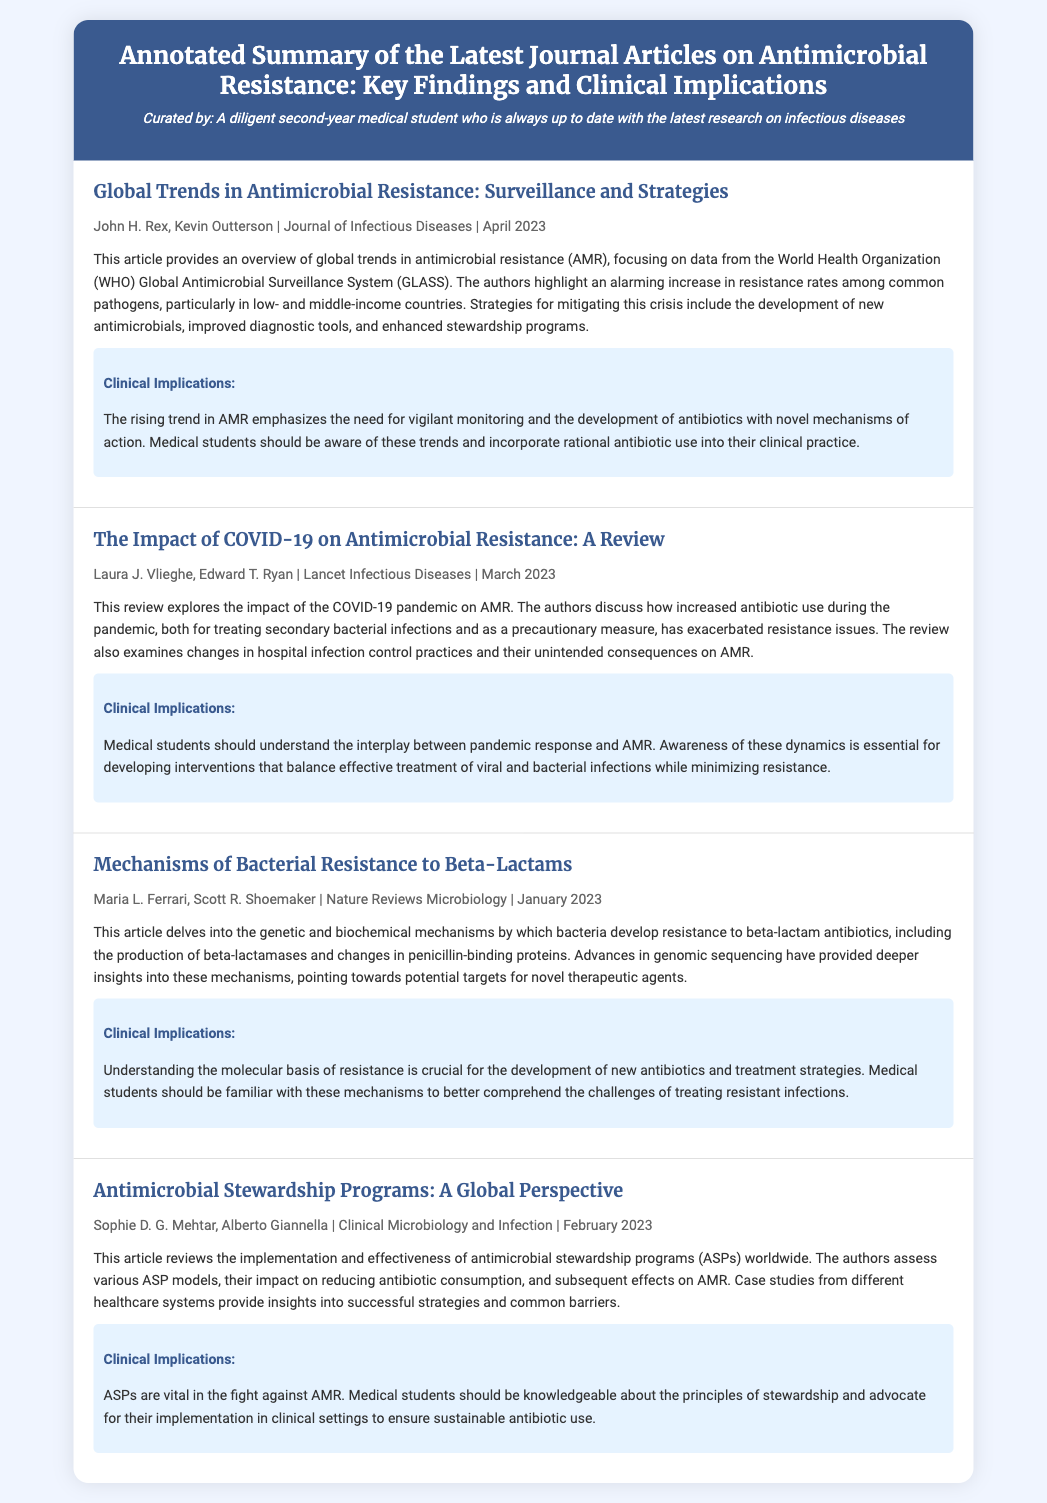What is the title of the first article? The title of the first article is provided in the document under the articles section.
Answer: Global Trends in Antimicrobial Resistance: Surveillance and Strategies Who are the authors of the article on COVID-19's impact on AMR? The authors are mentioned in the metadata of the article.
Answer: Laura J. Vlieghe, Edward T. Ryan What journal published the article discussing beta-lactams? The journal is specified in the metadata of the respective article.
Answer: Nature Reviews Microbiology When was the article on antimicrobial stewardship programs published? The publication date is included in the metadata for each article.
Answer: February 2023 What is one strategy mentioned to combat antimicrobial resistance? The strategies discussed in the articles provide insights into tackling AMR issues.
Answer: Development of new antimicrobials What is a key implication highlighted for medical students regarding AMR? The clinical implications are summarised for each article indicating what medical students should take away.
Answer: Incorporate rational antibiotic use What does ASP stand for? This abbreviation is explained within the context of the article focusing on stewardship.
Answer: Antimicrobial Stewardship Programs How does the COVID-19 pandemic affect antibiotic resistance? The summary contains information discussing the relationship between the pandemic and antibiotic resistance.
Answer: Increased antibiotic use 